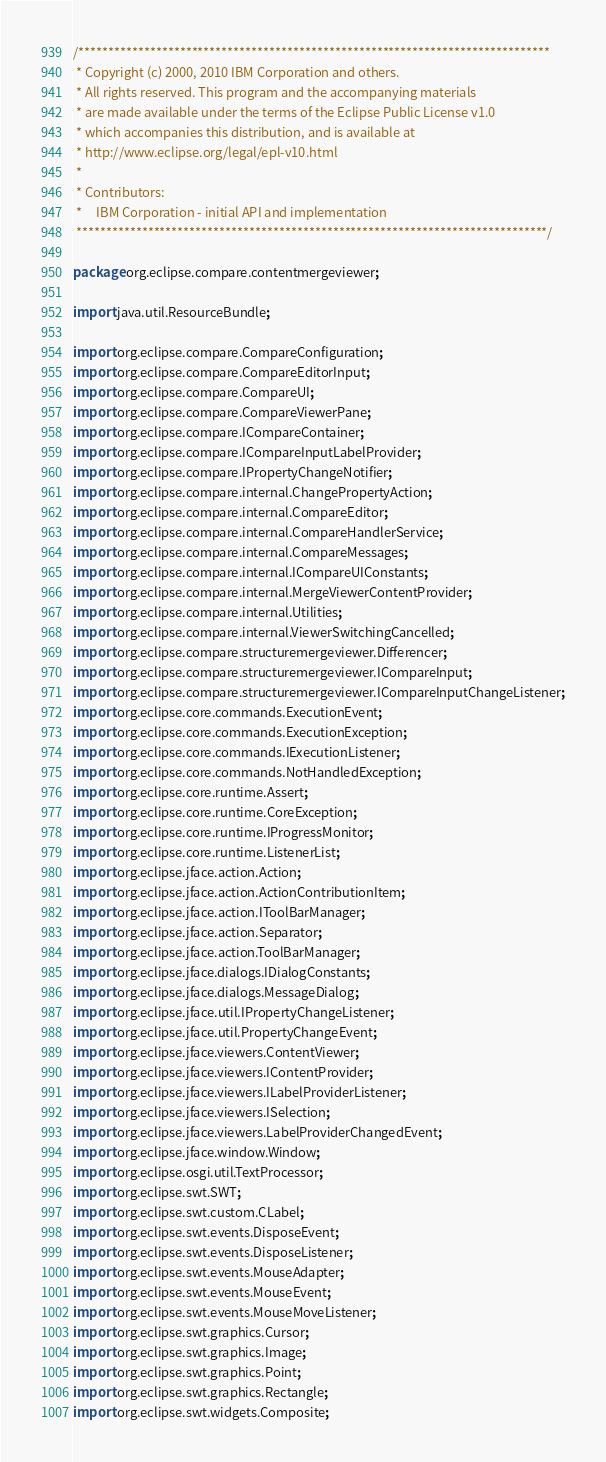<code> <loc_0><loc_0><loc_500><loc_500><_Java_>/*******************************************************************************
 * Copyright (c) 2000, 2010 IBM Corporation and others.
 * All rights reserved. This program and the accompanying materials
 * are made available under the terms of the Eclipse Public License v1.0
 * which accompanies this distribution, and is available at
 * http://www.eclipse.org/legal/epl-v10.html
 *
 * Contributors:
 *     IBM Corporation - initial API and implementation
 *******************************************************************************/

package org.eclipse.compare.contentmergeviewer;

import java.util.ResourceBundle;

import org.eclipse.compare.CompareConfiguration;
import org.eclipse.compare.CompareEditorInput;
import org.eclipse.compare.CompareUI;
import org.eclipse.compare.CompareViewerPane;
import org.eclipse.compare.ICompareContainer;
import org.eclipse.compare.ICompareInputLabelProvider;
import org.eclipse.compare.IPropertyChangeNotifier;
import org.eclipse.compare.internal.ChangePropertyAction;
import org.eclipse.compare.internal.CompareEditor;
import org.eclipse.compare.internal.CompareHandlerService;
import org.eclipse.compare.internal.CompareMessages;
import org.eclipse.compare.internal.ICompareUIConstants;
import org.eclipse.compare.internal.MergeViewerContentProvider;
import org.eclipse.compare.internal.Utilities;
import org.eclipse.compare.internal.ViewerSwitchingCancelled;
import org.eclipse.compare.structuremergeviewer.Differencer;
import org.eclipse.compare.structuremergeviewer.ICompareInput;
import org.eclipse.compare.structuremergeviewer.ICompareInputChangeListener;
import org.eclipse.core.commands.ExecutionEvent;
import org.eclipse.core.commands.ExecutionException;
import org.eclipse.core.commands.IExecutionListener;
import org.eclipse.core.commands.NotHandledException;
import org.eclipse.core.runtime.Assert;
import org.eclipse.core.runtime.CoreException;
import org.eclipse.core.runtime.IProgressMonitor;
import org.eclipse.core.runtime.ListenerList;
import org.eclipse.jface.action.Action;
import org.eclipse.jface.action.ActionContributionItem;
import org.eclipse.jface.action.IToolBarManager;
import org.eclipse.jface.action.Separator;
import org.eclipse.jface.action.ToolBarManager;
import org.eclipse.jface.dialogs.IDialogConstants;
import org.eclipse.jface.dialogs.MessageDialog;
import org.eclipse.jface.util.IPropertyChangeListener;
import org.eclipse.jface.util.PropertyChangeEvent;
import org.eclipse.jface.viewers.ContentViewer;
import org.eclipse.jface.viewers.IContentProvider;
import org.eclipse.jface.viewers.ILabelProviderListener;
import org.eclipse.jface.viewers.ISelection;
import org.eclipse.jface.viewers.LabelProviderChangedEvent;
import org.eclipse.jface.window.Window;
import org.eclipse.osgi.util.TextProcessor;
import org.eclipse.swt.SWT;
import org.eclipse.swt.custom.CLabel;
import org.eclipse.swt.events.DisposeEvent;
import org.eclipse.swt.events.DisposeListener;
import org.eclipse.swt.events.MouseAdapter;
import org.eclipse.swt.events.MouseEvent;
import org.eclipse.swt.events.MouseMoveListener;
import org.eclipse.swt.graphics.Cursor;
import org.eclipse.swt.graphics.Image;
import org.eclipse.swt.graphics.Point;
import org.eclipse.swt.graphics.Rectangle;
import org.eclipse.swt.widgets.Composite;</code> 